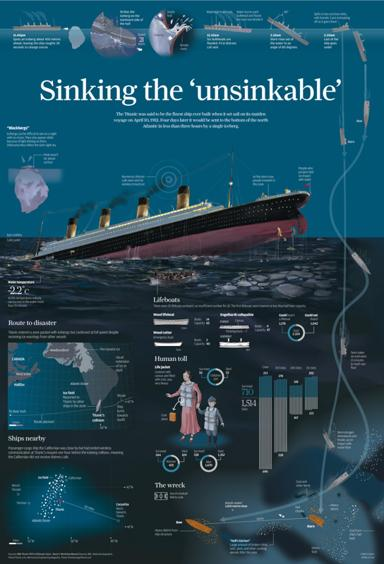What is the main topic of the image? The main topic of the image is the sinking of the Titanic, highlighted through various informative elements such as timelines, diagrams, and factual annotations. This infographic encapsulates the events that led to the sinking, specifics about the ship, and its aftermath. 